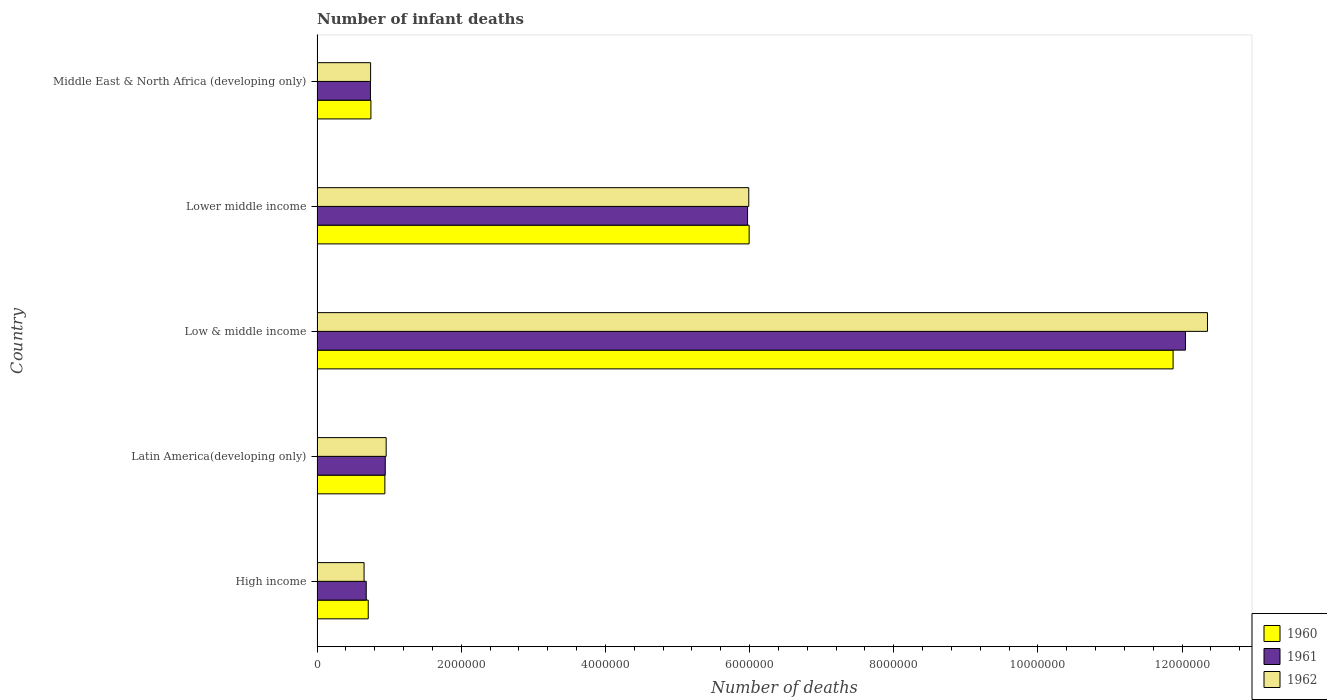How many groups of bars are there?
Offer a terse response. 5. Are the number of bars per tick equal to the number of legend labels?
Provide a short and direct response. Yes. Are the number of bars on each tick of the Y-axis equal?
Ensure brevity in your answer.  Yes. How many bars are there on the 1st tick from the top?
Give a very brief answer. 3. How many bars are there on the 3rd tick from the bottom?
Your answer should be compact. 3. What is the label of the 2nd group of bars from the top?
Ensure brevity in your answer.  Lower middle income. What is the number of infant deaths in 1961 in Lower middle income?
Offer a very short reply. 5.97e+06. Across all countries, what is the maximum number of infant deaths in 1961?
Provide a short and direct response. 1.20e+07. Across all countries, what is the minimum number of infant deaths in 1961?
Your answer should be very brief. 6.82e+05. What is the total number of infant deaths in 1960 in the graph?
Your response must be concise. 2.03e+07. What is the difference between the number of infant deaths in 1961 in Low & middle income and that in Middle East & North Africa (developing only)?
Provide a short and direct response. 1.13e+07. What is the difference between the number of infant deaths in 1962 in High income and the number of infant deaths in 1961 in Middle East & North Africa (developing only)?
Offer a very short reply. -8.85e+04. What is the average number of infant deaths in 1962 per country?
Your answer should be compact. 4.14e+06. What is the difference between the number of infant deaths in 1961 and number of infant deaths in 1960 in Middle East & North Africa (developing only)?
Offer a terse response. -6347. What is the ratio of the number of infant deaths in 1961 in High income to that in Latin America(developing only)?
Make the answer very short. 0.72. Is the difference between the number of infant deaths in 1961 in Latin America(developing only) and Middle East & North Africa (developing only) greater than the difference between the number of infant deaths in 1960 in Latin America(developing only) and Middle East & North Africa (developing only)?
Provide a short and direct response. Yes. What is the difference between the highest and the second highest number of infant deaths in 1960?
Ensure brevity in your answer.  5.88e+06. What is the difference between the highest and the lowest number of infant deaths in 1960?
Provide a short and direct response. 1.12e+07. What does the 1st bar from the bottom in Latin America(developing only) represents?
Provide a short and direct response. 1960. How many bars are there?
Ensure brevity in your answer.  15. How many countries are there in the graph?
Make the answer very short. 5. What is the difference between two consecutive major ticks on the X-axis?
Your answer should be very brief. 2.00e+06. Are the values on the major ticks of X-axis written in scientific E-notation?
Keep it short and to the point. No. Does the graph contain grids?
Offer a very short reply. No. Where does the legend appear in the graph?
Ensure brevity in your answer.  Bottom right. How many legend labels are there?
Ensure brevity in your answer.  3. What is the title of the graph?
Offer a very short reply. Number of infant deaths. Does "2001" appear as one of the legend labels in the graph?
Provide a succinct answer. No. What is the label or title of the X-axis?
Make the answer very short. Number of deaths. What is the Number of deaths in 1960 in High income?
Offer a very short reply. 7.10e+05. What is the Number of deaths of 1961 in High income?
Keep it short and to the point. 6.82e+05. What is the Number of deaths in 1962 in High income?
Give a very brief answer. 6.52e+05. What is the Number of deaths in 1960 in Latin America(developing only)?
Keep it short and to the point. 9.41e+05. What is the Number of deaths in 1961 in Latin America(developing only)?
Your answer should be very brief. 9.46e+05. What is the Number of deaths of 1962 in Latin America(developing only)?
Provide a short and direct response. 9.59e+05. What is the Number of deaths in 1960 in Low & middle income?
Provide a succinct answer. 1.19e+07. What is the Number of deaths of 1961 in Low & middle income?
Provide a succinct answer. 1.20e+07. What is the Number of deaths in 1962 in Low & middle income?
Offer a terse response. 1.24e+07. What is the Number of deaths of 1960 in Lower middle income?
Make the answer very short. 5.99e+06. What is the Number of deaths in 1961 in Lower middle income?
Give a very brief answer. 5.97e+06. What is the Number of deaths in 1962 in Lower middle income?
Your answer should be compact. 5.99e+06. What is the Number of deaths in 1960 in Middle East & North Africa (developing only)?
Give a very brief answer. 7.47e+05. What is the Number of deaths of 1961 in Middle East & North Africa (developing only)?
Your answer should be compact. 7.41e+05. What is the Number of deaths in 1962 in Middle East & North Africa (developing only)?
Offer a very short reply. 7.43e+05. Across all countries, what is the maximum Number of deaths in 1960?
Offer a terse response. 1.19e+07. Across all countries, what is the maximum Number of deaths in 1961?
Your answer should be compact. 1.20e+07. Across all countries, what is the maximum Number of deaths of 1962?
Your response must be concise. 1.24e+07. Across all countries, what is the minimum Number of deaths of 1960?
Make the answer very short. 7.10e+05. Across all countries, what is the minimum Number of deaths in 1961?
Give a very brief answer. 6.82e+05. Across all countries, what is the minimum Number of deaths in 1962?
Ensure brevity in your answer.  6.52e+05. What is the total Number of deaths of 1960 in the graph?
Your answer should be very brief. 2.03e+07. What is the total Number of deaths of 1961 in the graph?
Make the answer very short. 2.04e+07. What is the total Number of deaths in 1962 in the graph?
Provide a succinct answer. 2.07e+07. What is the difference between the Number of deaths in 1960 in High income and that in Latin America(developing only)?
Provide a short and direct response. -2.31e+05. What is the difference between the Number of deaths in 1961 in High income and that in Latin America(developing only)?
Your answer should be very brief. -2.64e+05. What is the difference between the Number of deaths of 1962 in High income and that in Latin America(developing only)?
Provide a short and direct response. -3.06e+05. What is the difference between the Number of deaths in 1960 in High income and that in Low & middle income?
Provide a short and direct response. -1.12e+07. What is the difference between the Number of deaths in 1961 in High income and that in Low & middle income?
Give a very brief answer. -1.14e+07. What is the difference between the Number of deaths in 1962 in High income and that in Low & middle income?
Make the answer very short. -1.17e+07. What is the difference between the Number of deaths in 1960 in High income and that in Lower middle income?
Make the answer very short. -5.28e+06. What is the difference between the Number of deaths in 1961 in High income and that in Lower middle income?
Your response must be concise. -5.29e+06. What is the difference between the Number of deaths in 1962 in High income and that in Lower middle income?
Your response must be concise. -5.34e+06. What is the difference between the Number of deaths of 1960 in High income and that in Middle East & North Africa (developing only)?
Keep it short and to the point. -3.71e+04. What is the difference between the Number of deaths of 1961 in High income and that in Middle East & North Africa (developing only)?
Your answer should be very brief. -5.83e+04. What is the difference between the Number of deaths in 1962 in High income and that in Middle East & North Africa (developing only)?
Your response must be concise. -9.07e+04. What is the difference between the Number of deaths of 1960 in Latin America(developing only) and that in Low & middle income?
Keep it short and to the point. -1.09e+07. What is the difference between the Number of deaths of 1961 in Latin America(developing only) and that in Low & middle income?
Offer a terse response. -1.11e+07. What is the difference between the Number of deaths in 1962 in Latin America(developing only) and that in Low & middle income?
Offer a terse response. -1.14e+07. What is the difference between the Number of deaths in 1960 in Latin America(developing only) and that in Lower middle income?
Offer a very short reply. -5.05e+06. What is the difference between the Number of deaths in 1961 in Latin America(developing only) and that in Lower middle income?
Your response must be concise. -5.03e+06. What is the difference between the Number of deaths of 1962 in Latin America(developing only) and that in Lower middle income?
Keep it short and to the point. -5.03e+06. What is the difference between the Number of deaths in 1960 in Latin America(developing only) and that in Middle East & North Africa (developing only)?
Your response must be concise. 1.94e+05. What is the difference between the Number of deaths of 1961 in Latin America(developing only) and that in Middle East & North Africa (developing only)?
Offer a terse response. 2.06e+05. What is the difference between the Number of deaths of 1962 in Latin America(developing only) and that in Middle East & North Africa (developing only)?
Offer a very short reply. 2.16e+05. What is the difference between the Number of deaths of 1960 in Low & middle income and that in Lower middle income?
Give a very brief answer. 5.88e+06. What is the difference between the Number of deaths in 1961 in Low & middle income and that in Lower middle income?
Provide a short and direct response. 6.07e+06. What is the difference between the Number of deaths of 1962 in Low & middle income and that in Lower middle income?
Your answer should be very brief. 6.36e+06. What is the difference between the Number of deaths in 1960 in Low & middle income and that in Middle East & North Africa (developing only)?
Keep it short and to the point. 1.11e+07. What is the difference between the Number of deaths of 1961 in Low & middle income and that in Middle East & North Africa (developing only)?
Ensure brevity in your answer.  1.13e+07. What is the difference between the Number of deaths of 1962 in Low & middle income and that in Middle East & North Africa (developing only)?
Provide a short and direct response. 1.16e+07. What is the difference between the Number of deaths of 1960 in Lower middle income and that in Middle East & North Africa (developing only)?
Ensure brevity in your answer.  5.25e+06. What is the difference between the Number of deaths of 1961 in Lower middle income and that in Middle East & North Africa (developing only)?
Keep it short and to the point. 5.23e+06. What is the difference between the Number of deaths of 1962 in Lower middle income and that in Middle East & North Africa (developing only)?
Your answer should be very brief. 5.25e+06. What is the difference between the Number of deaths of 1960 in High income and the Number of deaths of 1961 in Latin America(developing only)?
Give a very brief answer. -2.36e+05. What is the difference between the Number of deaths of 1960 in High income and the Number of deaths of 1962 in Latin America(developing only)?
Your response must be concise. -2.49e+05. What is the difference between the Number of deaths in 1961 in High income and the Number of deaths in 1962 in Latin America(developing only)?
Keep it short and to the point. -2.76e+05. What is the difference between the Number of deaths of 1960 in High income and the Number of deaths of 1961 in Low & middle income?
Your response must be concise. -1.13e+07. What is the difference between the Number of deaths of 1960 in High income and the Number of deaths of 1962 in Low & middle income?
Keep it short and to the point. -1.16e+07. What is the difference between the Number of deaths of 1961 in High income and the Number of deaths of 1962 in Low & middle income?
Provide a short and direct response. -1.17e+07. What is the difference between the Number of deaths of 1960 in High income and the Number of deaths of 1961 in Lower middle income?
Ensure brevity in your answer.  -5.26e+06. What is the difference between the Number of deaths of 1960 in High income and the Number of deaths of 1962 in Lower middle income?
Your response must be concise. -5.28e+06. What is the difference between the Number of deaths of 1961 in High income and the Number of deaths of 1962 in Lower middle income?
Make the answer very short. -5.31e+06. What is the difference between the Number of deaths in 1960 in High income and the Number of deaths in 1961 in Middle East & North Africa (developing only)?
Offer a very short reply. -3.07e+04. What is the difference between the Number of deaths in 1960 in High income and the Number of deaths in 1962 in Middle East & North Africa (developing only)?
Offer a terse response. -3.30e+04. What is the difference between the Number of deaths of 1961 in High income and the Number of deaths of 1962 in Middle East & North Africa (developing only)?
Your answer should be compact. -6.06e+04. What is the difference between the Number of deaths of 1960 in Latin America(developing only) and the Number of deaths of 1961 in Low & middle income?
Your response must be concise. -1.11e+07. What is the difference between the Number of deaths in 1960 in Latin America(developing only) and the Number of deaths in 1962 in Low & middle income?
Your answer should be very brief. -1.14e+07. What is the difference between the Number of deaths of 1961 in Latin America(developing only) and the Number of deaths of 1962 in Low & middle income?
Give a very brief answer. -1.14e+07. What is the difference between the Number of deaths of 1960 in Latin America(developing only) and the Number of deaths of 1961 in Lower middle income?
Your response must be concise. -5.03e+06. What is the difference between the Number of deaths in 1960 in Latin America(developing only) and the Number of deaths in 1962 in Lower middle income?
Your response must be concise. -5.05e+06. What is the difference between the Number of deaths of 1961 in Latin America(developing only) and the Number of deaths of 1962 in Lower middle income?
Offer a very short reply. -5.04e+06. What is the difference between the Number of deaths in 1960 in Latin America(developing only) and the Number of deaths in 1961 in Middle East & North Africa (developing only)?
Provide a short and direct response. 2.00e+05. What is the difference between the Number of deaths of 1960 in Latin America(developing only) and the Number of deaths of 1962 in Middle East & North Africa (developing only)?
Your answer should be very brief. 1.98e+05. What is the difference between the Number of deaths in 1961 in Latin America(developing only) and the Number of deaths in 1962 in Middle East & North Africa (developing only)?
Offer a very short reply. 2.03e+05. What is the difference between the Number of deaths in 1960 in Low & middle income and the Number of deaths in 1961 in Lower middle income?
Make the answer very short. 5.90e+06. What is the difference between the Number of deaths of 1960 in Low & middle income and the Number of deaths of 1962 in Lower middle income?
Provide a succinct answer. 5.89e+06. What is the difference between the Number of deaths in 1961 in Low & middle income and the Number of deaths in 1962 in Lower middle income?
Your answer should be very brief. 6.06e+06. What is the difference between the Number of deaths of 1960 in Low & middle income and the Number of deaths of 1961 in Middle East & North Africa (developing only)?
Provide a short and direct response. 1.11e+07. What is the difference between the Number of deaths in 1960 in Low & middle income and the Number of deaths in 1962 in Middle East & North Africa (developing only)?
Offer a terse response. 1.11e+07. What is the difference between the Number of deaths in 1961 in Low & middle income and the Number of deaths in 1962 in Middle East & North Africa (developing only)?
Provide a short and direct response. 1.13e+07. What is the difference between the Number of deaths in 1960 in Lower middle income and the Number of deaths in 1961 in Middle East & North Africa (developing only)?
Make the answer very short. 5.25e+06. What is the difference between the Number of deaths of 1960 in Lower middle income and the Number of deaths of 1962 in Middle East & North Africa (developing only)?
Ensure brevity in your answer.  5.25e+06. What is the difference between the Number of deaths of 1961 in Lower middle income and the Number of deaths of 1962 in Middle East & North Africa (developing only)?
Provide a short and direct response. 5.23e+06. What is the average Number of deaths in 1960 per country?
Your answer should be compact. 4.05e+06. What is the average Number of deaths of 1961 per country?
Ensure brevity in your answer.  4.08e+06. What is the average Number of deaths of 1962 per country?
Your response must be concise. 4.14e+06. What is the difference between the Number of deaths of 1960 and Number of deaths of 1961 in High income?
Your answer should be very brief. 2.76e+04. What is the difference between the Number of deaths of 1960 and Number of deaths of 1962 in High income?
Provide a succinct answer. 5.77e+04. What is the difference between the Number of deaths in 1961 and Number of deaths in 1962 in High income?
Provide a succinct answer. 3.01e+04. What is the difference between the Number of deaths in 1960 and Number of deaths in 1961 in Latin America(developing only)?
Keep it short and to the point. -5681. What is the difference between the Number of deaths of 1960 and Number of deaths of 1962 in Latin America(developing only)?
Your answer should be compact. -1.81e+04. What is the difference between the Number of deaths in 1961 and Number of deaths in 1962 in Latin America(developing only)?
Offer a terse response. -1.24e+04. What is the difference between the Number of deaths of 1960 and Number of deaths of 1961 in Low & middle income?
Keep it short and to the point. -1.71e+05. What is the difference between the Number of deaths of 1960 and Number of deaths of 1962 in Low & middle income?
Your answer should be very brief. -4.77e+05. What is the difference between the Number of deaths of 1961 and Number of deaths of 1962 in Low & middle income?
Provide a short and direct response. -3.06e+05. What is the difference between the Number of deaths in 1960 and Number of deaths in 1961 in Lower middle income?
Your answer should be very brief. 2.19e+04. What is the difference between the Number of deaths of 1960 and Number of deaths of 1962 in Lower middle income?
Provide a succinct answer. 5119. What is the difference between the Number of deaths of 1961 and Number of deaths of 1962 in Lower middle income?
Ensure brevity in your answer.  -1.68e+04. What is the difference between the Number of deaths of 1960 and Number of deaths of 1961 in Middle East & North Africa (developing only)?
Keep it short and to the point. 6347. What is the difference between the Number of deaths of 1960 and Number of deaths of 1962 in Middle East & North Africa (developing only)?
Your answer should be very brief. 4075. What is the difference between the Number of deaths of 1961 and Number of deaths of 1962 in Middle East & North Africa (developing only)?
Give a very brief answer. -2272. What is the ratio of the Number of deaths of 1960 in High income to that in Latin America(developing only)?
Offer a very short reply. 0.75. What is the ratio of the Number of deaths of 1961 in High income to that in Latin America(developing only)?
Give a very brief answer. 0.72. What is the ratio of the Number of deaths of 1962 in High income to that in Latin America(developing only)?
Keep it short and to the point. 0.68. What is the ratio of the Number of deaths in 1960 in High income to that in Low & middle income?
Your answer should be very brief. 0.06. What is the ratio of the Number of deaths of 1961 in High income to that in Low & middle income?
Ensure brevity in your answer.  0.06. What is the ratio of the Number of deaths of 1962 in High income to that in Low & middle income?
Ensure brevity in your answer.  0.05. What is the ratio of the Number of deaths of 1960 in High income to that in Lower middle income?
Offer a very short reply. 0.12. What is the ratio of the Number of deaths in 1961 in High income to that in Lower middle income?
Offer a very short reply. 0.11. What is the ratio of the Number of deaths of 1962 in High income to that in Lower middle income?
Make the answer very short. 0.11. What is the ratio of the Number of deaths in 1960 in High income to that in Middle East & North Africa (developing only)?
Ensure brevity in your answer.  0.95. What is the ratio of the Number of deaths in 1961 in High income to that in Middle East & North Africa (developing only)?
Ensure brevity in your answer.  0.92. What is the ratio of the Number of deaths of 1962 in High income to that in Middle East & North Africa (developing only)?
Make the answer very short. 0.88. What is the ratio of the Number of deaths of 1960 in Latin America(developing only) to that in Low & middle income?
Provide a succinct answer. 0.08. What is the ratio of the Number of deaths in 1961 in Latin America(developing only) to that in Low & middle income?
Your answer should be compact. 0.08. What is the ratio of the Number of deaths in 1962 in Latin America(developing only) to that in Low & middle income?
Keep it short and to the point. 0.08. What is the ratio of the Number of deaths in 1960 in Latin America(developing only) to that in Lower middle income?
Make the answer very short. 0.16. What is the ratio of the Number of deaths of 1961 in Latin America(developing only) to that in Lower middle income?
Provide a succinct answer. 0.16. What is the ratio of the Number of deaths in 1962 in Latin America(developing only) to that in Lower middle income?
Make the answer very short. 0.16. What is the ratio of the Number of deaths of 1960 in Latin America(developing only) to that in Middle East & North Africa (developing only)?
Provide a short and direct response. 1.26. What is the ratio of the Number of deaths in 1961 in Latin America(developing only) to that in Middle East & North Africa (developing only)?
Make the answer very short. 1.28. What is the ratio of the Number of deaths in 1962 in Latin America(developing only) to that in Middle East & North Africa (developing only)?
Provide a short and direct response. 1.29. What is the ratio of the Number of deaths of 1960 in Low & middle income to that in Lower middle income?
Provide a short and direct response. 1.98. What is the ratio of the Number of deaths of 1961 in Low & middle income to that in Lower middle income?
Ensure brevity in your answer.  2.02. What is the ratio of the Number of deaths of 1962 in Low & middle income to that in Lower middle income?
Offer a very short reply. 2.06. What is the ratio of the Number of deaths in 1960 in Low & middle income to that in Middle East & North Africa (developing only)?
Your answer should be compact. 15.89. What is the ratio of the Number of deaths of 1961 in Low & middle income to that in Middle East & North Africa (developing only)?
Provide a short and direct response. 16.26. What is the ratio of the Number of deaths in 1962 in Low & middle income to that in Middle East & North Africa (developing only)?
Ensure brevity in your answer.  16.62. What is the ratio of the Number of deaths in 1960 in Lower middle income to that in Middle East & North Africa (developing only)?
Your answer should be very brief. 8.02. What is the ratio of the Number of deaths of 1961 in Lower middle income to that in Middle East & North Africa (developing only)?
Your answer should be very brief. 8.06. What is the ratio of the Number of deaths of 1962 in Lower middle income to that in Middle East & North Africa (developing only)?
Provide a short and direct response. 8.06. What is the difference between the highest and the second highest Number of deaths of 1960?
Provide a short and direct response. 5.88e+06. What is the difference between the highest and the second highest Number of deaths in 1961?
Make the answer very short. 6.07e+06. What is the difference between the highest and the second highest Number of deaths of 1962?
Keep it short and to the point. 6.36e+06. What is the difference between the highest and the lowest Number of deaths in 1960?
Your answer should be very brief. 1.12e+07. What is the difference between the highest and the lowest Number of deaths in 1961?
Offer a very short reply. 1.14e+07. What is the difference between the highest and the lowest Number of deaths in 1962?
Ensure brevity in your answer.  1.17e+07. 